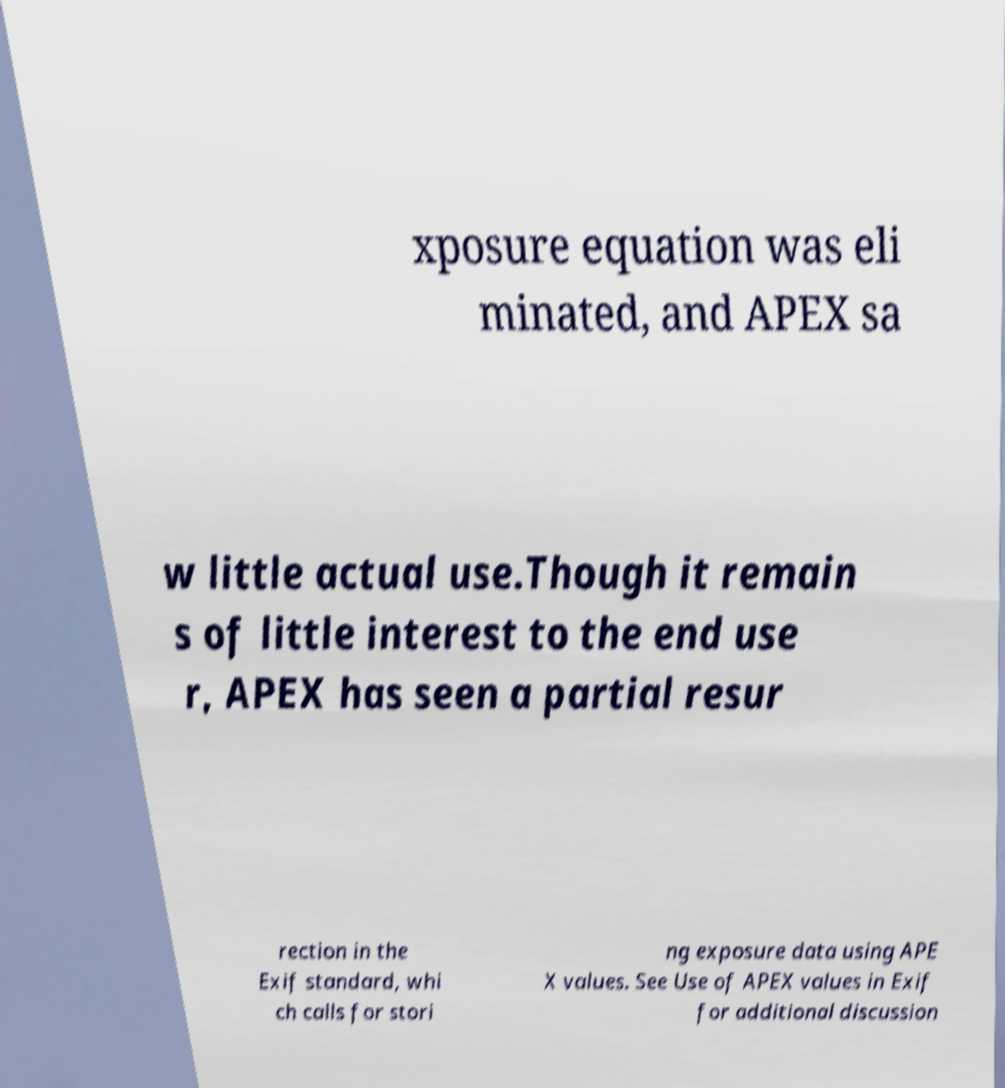What messages or text are displayed in this image? I need them in a readable, typed format. xposure equation was eli minated, and APEX sa w little actual use.Though it remain s of little interest to the end use r, APEX has seen a partial resur rection in the Exif standard, whi ch calls for stori ng exposure data using APE X values. See Use of APEX values in Exif for additional discussion 